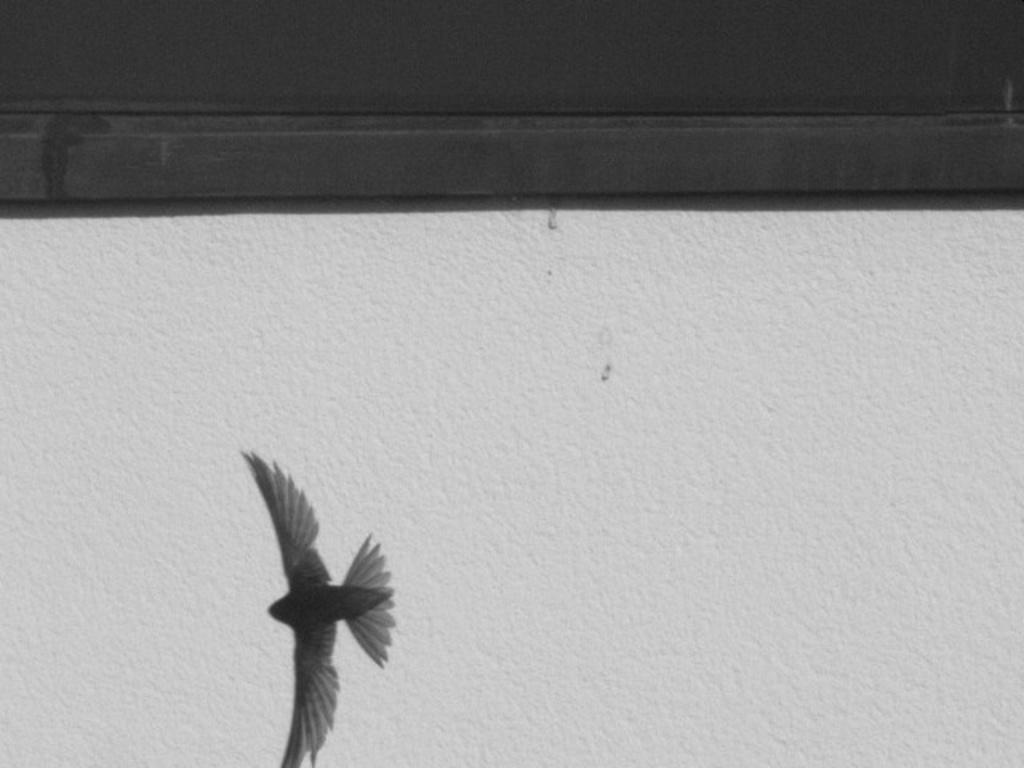In one or two sentences, can you explain what this image depicts? At the bottom of the image there is a bird flying. Here I can see a wall. At the top of the image there is a wooden plank. 